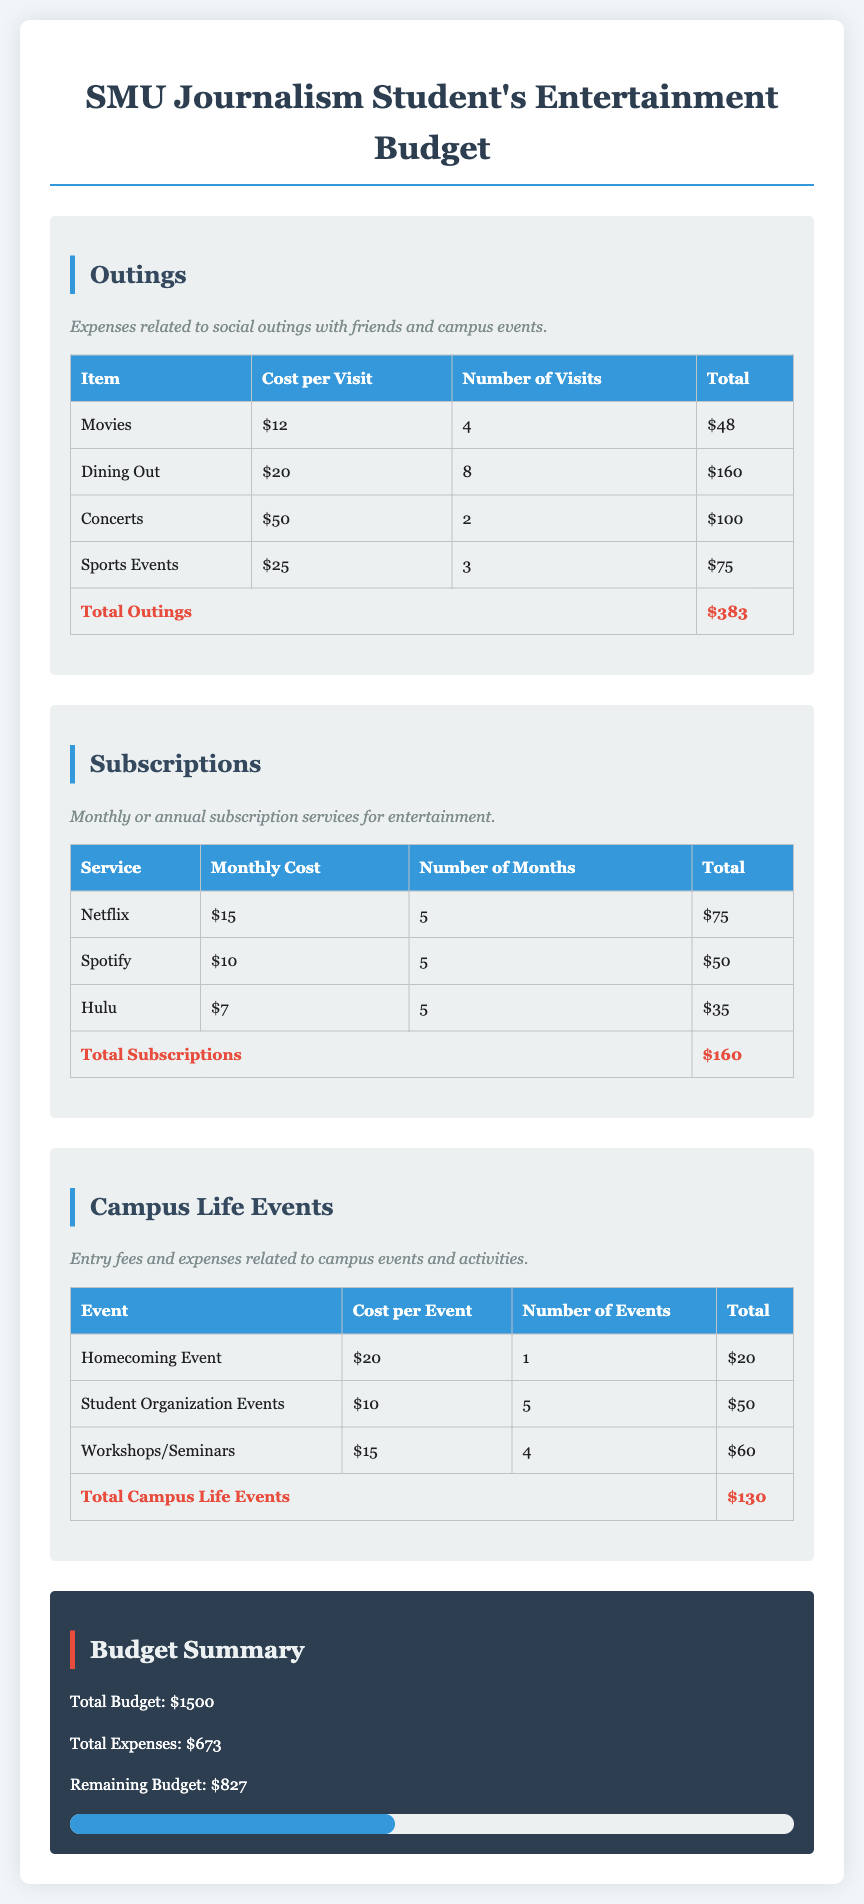What is the total cost for Movies? The total cost for Movies is calculated by multiplying the cost per visit by the number of visits: $12 * 4 = $48.
Answer: $48 How many visits are planned for Dining Out? The document states that there are 8 visits planned for Dining Out.
Answer: 8 What is the total cost for Subscriptions? The total cost for Subscriptions is the sum of all subscription costs, which is $75 + $50 + $35 = $160.
Answer: $160 What is the cost per event for the Homecoming Event? The document mentions the cost per event for the Homecoming Event is $20.
Answer: $20 What is the remaining budget after expenses? The remaining budget is calculated by subtracting total expenses from total budget: $1500 - $673 = $827.
Answer: $827 Which subscription service costs the least per month? The subscription service that costs the least per month is Hulu, at $7.
Answer: Hulu What are the total expenses for Campus Life Events? The total expenses for Campus Life Events are calculated as the sum of each event's total: $20 + $50 + $60 = $130.
Answer: $130 How many total outings are planned for the semester? The total number of outings planned combines all outings: 4 + 8 + 2 + 3 = 17 visits.
Answer: 17 